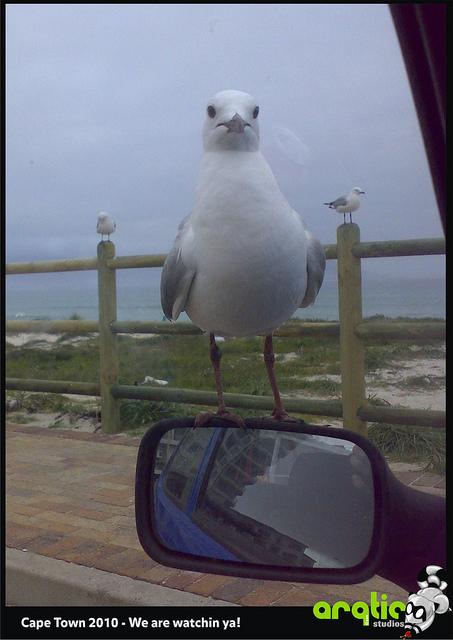Is the bird alive?
Write a very short answer. Yes. What is standing on the mirror?
Short answer required. Bird. How would you feel if you saw this outside of your car window?
Give a very brief answer. Surprised. 